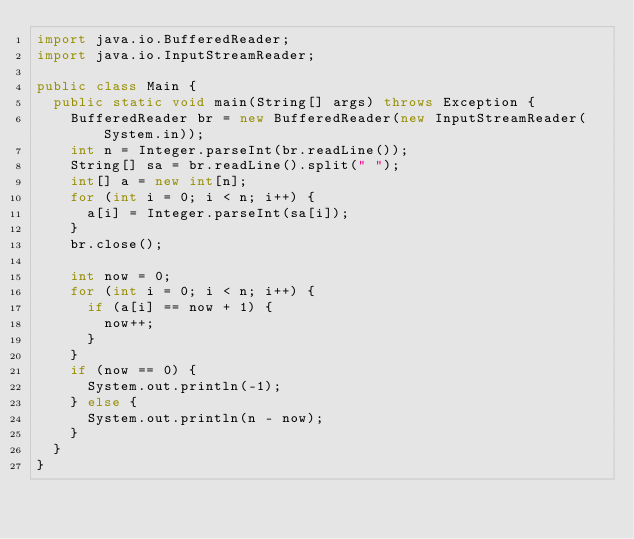<code> <loc_0><loc_0><loc_500><loc_500><_Java_>import java.io.BufferedReader;
import java.io.InputStreamReader;

public class Main {
	public static void main(String[] args) throws Exception {
		BufferedReader br = new BufferedReader(new InputStreamReader(System.in));
		int n = Integer.parseInt(br.readLine());
		String[] sa = br.readLine().split(" ");
		int[] a = new int[n];
		for (int i = 0; i < n; i++) {
			a[i] = Integer.parseInt(sa[i]);
		}
		br.close();

		int now = 0;
		for (int i = 0; i < n; i++) {
			if (a[i] == now + 1) {
				now++;
			}
		}
		if (now == 0) {
			System.out.println(-1);
		} else {
			System.out.println(n - now);
		}
	}
}
</code> 